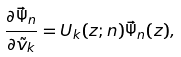Convert formula to latex. <formula><loc_0><loc_0><loc_500><loc_500>\frac { \partial \vec { \Psi } _ { n } } { \partial \tilde { v } _ { k } } = U _ { k } ( z ; n ) \vec { \Psi } _ { n } ( z ) ,</formula> 